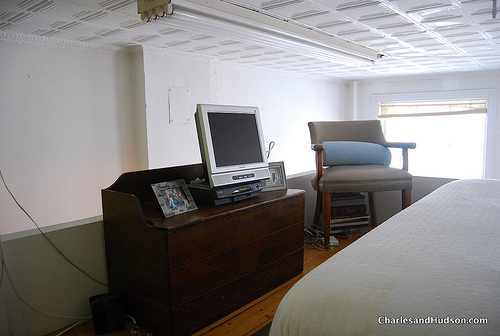What is the piece of furniture to the right of the silver device? The piece of furniture to the right of the silver device, a television, is actually a gray chair. 